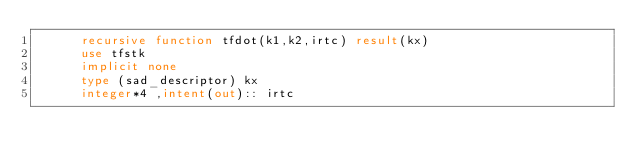<code> <loc_0><loc_0><loc_500><loc_500><_FORTRAN_>      recursive function tfdot(k1,k2,irtc) result(kx)
      use tfstk
      implicit none
      type (sad_descriptor) kx
      integer*4 ,intent(out):: irtc</code> 